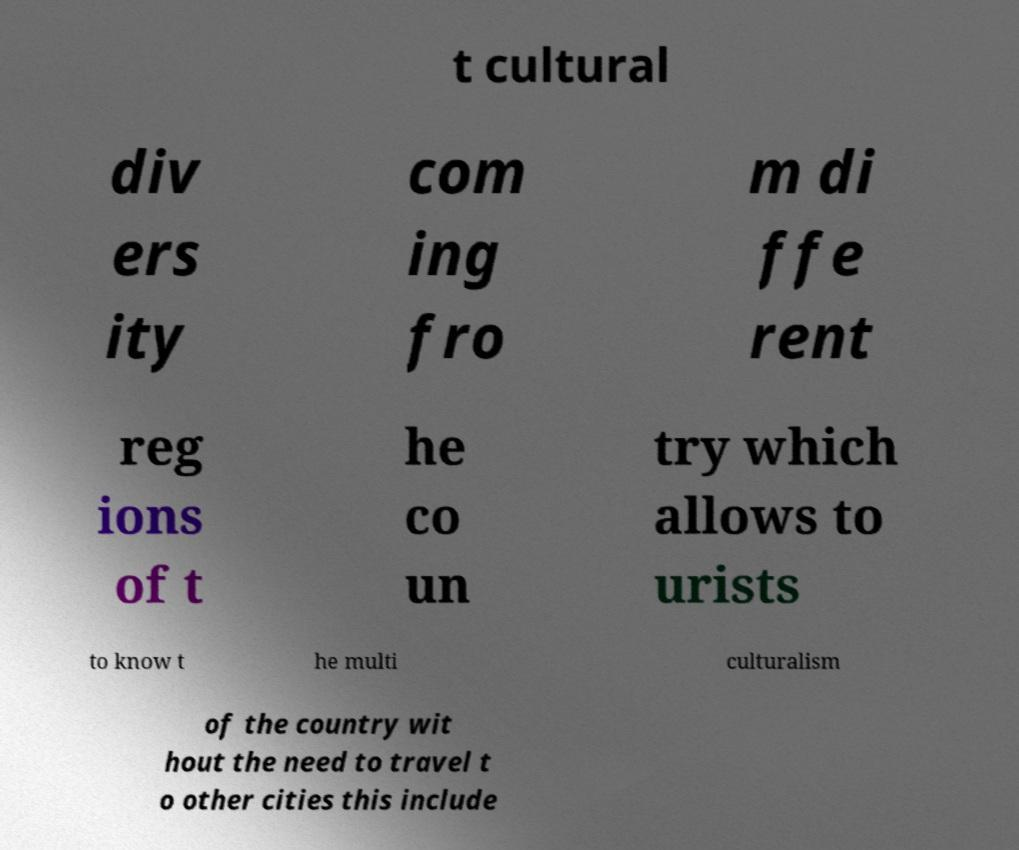What messages or text are displayed in this image? I need them in a readable, typed format. t cultural div ers ity com ing fro m di ffe rent reg ions of t he co un try which allows to urists to know t he multi culturalism of the country wit hout the need to travel t o other cities this include 